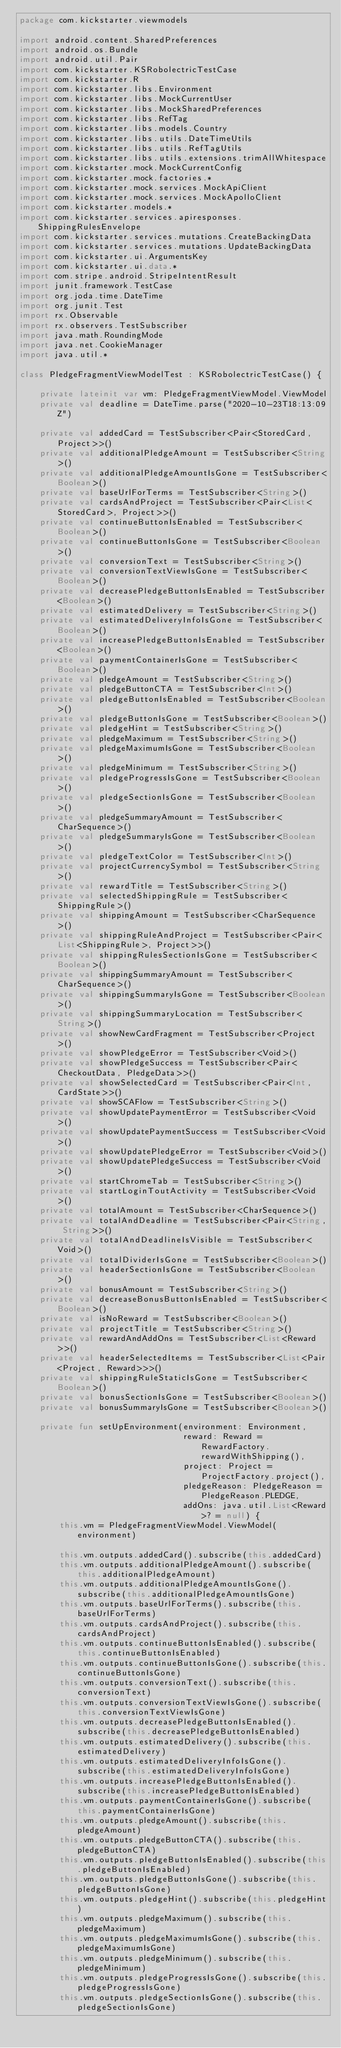Convert code to text. <code><loc_0><loc_0><loc_500><loc_500><_Kotlin_>package com.kickstarter.viewmodels

import android.content.SharedPreferences
import android.os.Bundle
import android.util.Pair
import com.kickstarter.KSRobolectricTestCase
import com.kickstarter.R
import com.kickstarter.libs.Environment
import com.kickstarter.libs.MockCurrentUser
import com.kickstarter.libs.MockSharedPreferences
import com.kickstarter.libs.RefTag
import com.kickstarter.libs.models.Country
import com.kickstarter.libs.utils.DateTimeUtils
import com.kickstarter.libs.utils.RefTagUtils
import com.kickstarter.libs.utils.extensions.trimAllWhitespace
import com.kickstarter.mock.MockCurrentConfig
import com.kickstarter.mock.factories.*
import com.kickstarter.mock.services.MockApiClient
import com.kickstarter.mock.services.MockApolloClient
import com.kickstarter.models.*
import com.kickstarter.services.apiresponses.ShippingRulesEnvelope
import com.kickstarter.services.mutations.CreateBackingData
import com.kickstarter.services.mutations.UpdateBackingData
import com.kickstarter.ui.ArgumentsKey
import com.kickstarter.ui.data.*
import com.stripe.android.StripeIntentResult
import junit.framework.TestCase
import org.joda.time.DateTime
import org.junit.Test
import rx.Observable
import rx.observers.TestSubscriber
import java.math.RoundingMode
import java.net.CookieManager
import java.util.*

class PledgeFragmentViewModelTest : KSRobolectricTestCase() {

    private lateinit var vm: PledgeFragmentViewModel.ViewModel
    private val deadline = DateTime.parse("2020-10-23T18:13:09Z")

    private val addedCard = TestSubscriber<Pair<StoredCard, Project>>()
    private val additionalPledgeAmount = TestSubscriber<String>()
    private val additionalPledgeAmountIsGone = TestSubscriber<Boolean>()
    private val baseUrlForTerms = TestSubscriber<String>()
    private val cardsAndProject = TestSubscriber<Pair<List<StoredCard>, Project>>()
    private val continueButtonIsEnabled = TestSubscriber<Boolean>()
    private val continueButtonIsGone = TestSubscriber<Boolean>()
    private val conversionText = TestSubscriber<String>()
    private val conversionTextViewIsGone = TestSubscriber<Boolean>()
    private val decreasePledgeButtonIsEnabled = TestSubscriber<Boolean>()
    private val estimatedDelivery = TestSubscriber<String>()
    private val estimatedDeliveryInfoIsGone = TestSubscriber<Boolean>()
    private val increasePledgeButtonIsEnabled = TestSubscriber<Boolean>()
    private val paymentContainerIsGone = TestSubscriber<Boolean>()
    private val pledgeAmount = TestSubscriber<String>()
    private val pledgeButtonCTA = TestSubscriber<Int>()
    private val pledgeButtonIsEnabled = TestSubscriber<Boolean>()
    private val pledgeButtonIsGone = TestSubscriber<Boolean>()
    private val pledgeHint = TestSubscriber<String>()
    private val pledgeMaximum = TestSubscriber<String>()
    private val pledgeMaximumIsGone = TestSubscriber<Boolean>()
    private val pledgeMinimum = TestSubscriber<String>()
    private val pledgeProgressIsGone = TestSubscriber<Boolean>()
    private val pledgeSectionIsGone = TestSubscriber<Boolean>()
    private val pledgeSummaryAmount = TestSubscriber<CharSequence>()
    private val pledgeSummaryIsGone = TestSubscriber<Boolean>()
    private val pledgeTextColor = TestSubscriber<Int>()
    private val projectCurrencySymbol = TestSubscriber<String>()
    private val rewardTitle = TestSubscriber<String>()
    private val selectedShippingRule = TestSubscriber<ShippingRule>()
    private val shippingAmount = TestSubscriber<CharSequence>()
    private val shippingRuleAndProject = TestSubscriber<Pair<List<ShippingRule>, Project>>()
    private val shippingRulesSectionIsGone = TestSubscriber<Boolean>()
    private val shippingSummaryAmount = TestSubscriber<CharSequence>()
    private val shippingSummaryIsGone = TestSubscriber<Boolean>()
    private val shippingSummaryLocation = TestSubscriber<String>()
    private val showNewCardFragment = TestSubscriber<Project>()
    private val showPledgeError = TestSubscriber<Void>()
    private val showPledgeSuccess = TestSubscriber<Pair<CheckoutData, PledgeData>>()
    private val showSelectedCard = TestSubscriber<Pair<Int, CardState>>()
    private val showSCAFlow = TestSubscriber<String>()
    private val showUpdatePaymentError = TestSubscriber<Void>()
    private val showUpdatePaymentSuccess = TestSubscriber<Void>()
    private val showUpdatePledgeError = TestSubscriber<Void>()
    private val showUpdatePledgeSuccess = TestSubscriber<Void>()
    private val startChromeTab = TestSubscriber<String>()
    private val startLoginToutActivity = TestSubscriber<Void>()
    private val totalAmount = TestSubscriber<CharSequence>()
    private val totalAndDeadline = TestSubscriber<Pair<String, String>>()
    private val totalAndDeadlineIsVisible = TestSubscriber<Void>()
    private val totalDividerIsGone = TestSubscriber<Boolean>()
    private val headerSectionIsGone = TestSubscriber<Boolean>()
    private val bonusAmount = TestSubscriber<String>()
    private val decreaseBonusButtonIsEnabled = TestSubscriber<Boolean>()
    private val isNoReward = TestSubscriber<Boolean>()
    private val projectTitle = TestSubscriber<String>()
    private val rewardAndAddOns = TestSubscriber<List<Reward>>()
    private val headerSelectedItems = TestSubscriber<List<Pair<Project, Reward>>>()
    private val shippingRuleStaticIsGone = TestSubscriber<Boolean>()
    private val bonusSectionIsGone = TestSubscriber<Boolean>()
    private val bonusSummaryIsGone = TestSubscriber<Boolean>()

    private fun setUpEnvironment(environment: Environment,
                                 reward: Reward = RewardFactory.rewardWithShipping(),
                                 project: Project = ProjectFactory.project(),
                                 pledgeReason: PledgeReason = PledgeReason.PLEDGE,
                                 addOns: java.util.List<Reward>? = null) {
        this.vm = PledgeFragmentViewModel.ViewModel(environment)

        this.vm.outputs.addedCard().subscribe(this.addedCard)
        this.vm.outputs.additionalPledgeAmount().subscribe(this.additionalPledgeAmount)
        this.vm.outputs.additionalPledgeAmountIsGone().subscribe(this.additionalPledgeAmountIsGone)
        this.vm.outputs.baseUrlForTerms().subscribe(this.baseUrlForTerms)
        this.vm.outputs.cardsAndProject().subscribe(this.cardsAndProject)
        this.vm.outputs.continueButtonIsEnabled().subscribe(this.continueButtonIsEnabled)
        this.vm.outputs.continueButtonIsGone().subscribe(this.continueButtonIsGone)
        this.vm.outputs.conversionText().subscribe(this.conversionText)
        this.vm.outputs.conversionTextViewIsGone().subscribe(this.conversionTextViewIsGone)
        this.vm.outputs.decreasePledgeButtonIsEnabled().subscribe(this.decreasePledgeButtonIsEnabled)
        this.vm.outputs.estimatedDelivery().subscribe(this.estimatedDelivery)
        this.vm.outputs.estimatedDeliveryInfoIsGone().subscribe(this.estimatedDeliveryInfoIsGone)
        this.vm.outputs.increasePledgeButtonIsEnabled().subscribe(this.increasePledgeButtonIsEnabled)
        this.vm.outputs.paymentContainerIsGone().subscribe(this.paymentContainerIsGone)
        this.vm.outputs.pledgeAmount().subscribe(this.pledgeAmount)
        this.vm.outputs.pledgeButtonCTA().subscribe(this.pledgeButtonCTA)
        this.vm.outputs.pledgeButtonIsEnabled().subscribe(this.pledgeButtonIsEnabled)
        this.vm.outputs.pledgeButtonIsGone().subscribe(this.pledgeButtonIsGone)
        this.vm.outputs.pledgeHint().subscribe(this.pledgeHint)
        this.vm.outputs.pledgeMaximum().subscribe(this.pledgeMaximum)
        this.vm.outputs.pledgeMaximumIsGone().subscribe(this.pledgeMaximumIsGone)
        this.vm.outputs.pledgeMinimum().subscribe(this.pledgeMinimum)
        this.vm.outputs.pledgeProgressIsGone().subscribe(this.pledgeProgressIsGone)
        this.vm.outputs.pledgeSectionIsGone().subscribe(this.pledgeSectionIsGone)</code> 